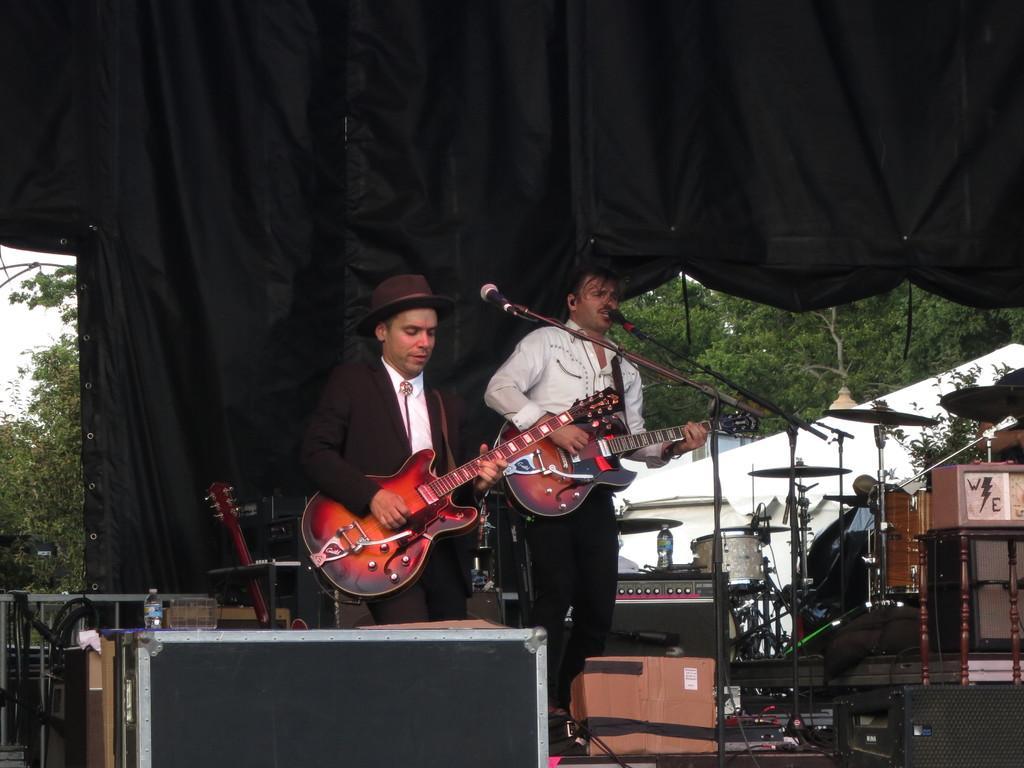Could you give a brief overview of what you see in this image? As we can see in the image there is a black color cloth. Two people standing and holding guitars in their hands and there is a mike and on the right side there are musical drums. 